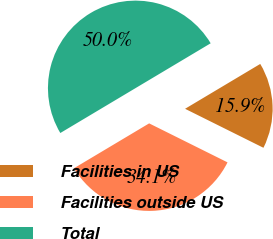Convert chart. <chart><loc_0><loc_0><loc_500><loc_500><pie_chart><fcel>Facilities in US<fcel>Facilities outside US<fcel>Total<nl><fcel>15.91%<fcel>34.09%<fcel>50.0%<nl></chart> 